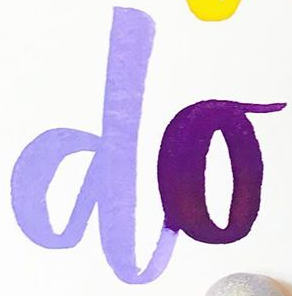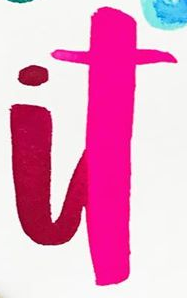Read the text content from these images in order, separated by a semicolon. do; it 